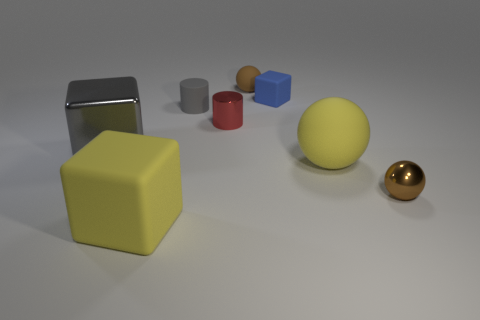Are there any reflections visible on the objects? Yes, several objects exhibit reflections. The large silver rectangle and the gold sphere display the most notable reflections, highlighting their shiny, metallic surfaces. The reflections contribute to the realism of the scene and offer clues about the lighting and environment out of frame. Which object stands out the most to you and why? The gold sphere stands out prominently due to its reflective surface and positioning in the image; its placement in the scene captures the light and attention differently compared to the more matte textures of the other objects. 